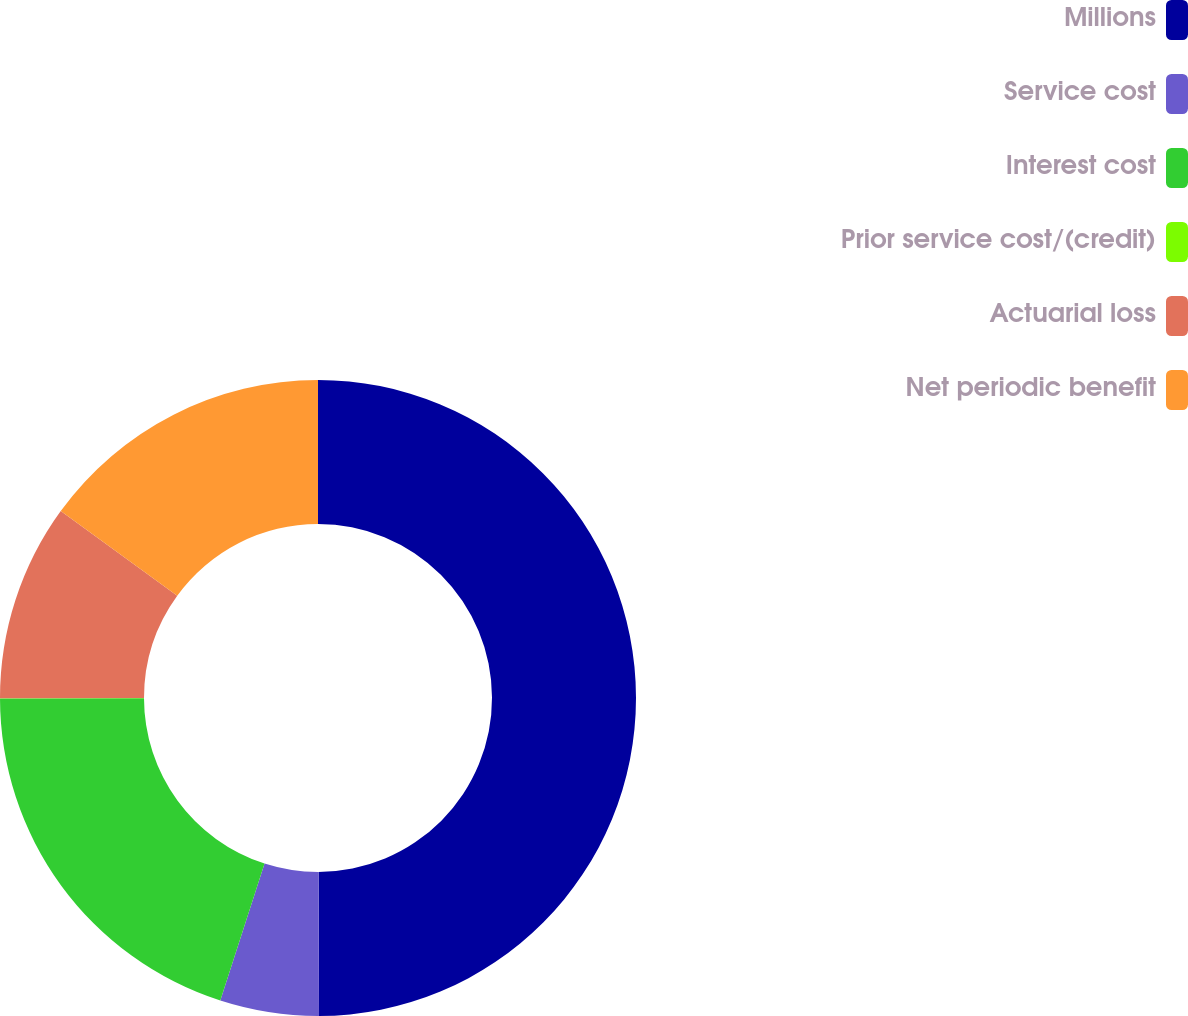Convert chart to OTSL. <chart><loc_0><loc_0><loc_500><loc_500><pie_chart><fcel>Millions<fcel>Service cost<fcel>Interest cost<fcel>Prior service cost/(credit)<fcel>Actuarial loss<fcel>Net periodic benefit<nl><fcel>49.95%<fcel>5.02%<fcel>20.0%<fcel>0.02%<fcel>10.01%<fcel>15.0%<nl></chart> 